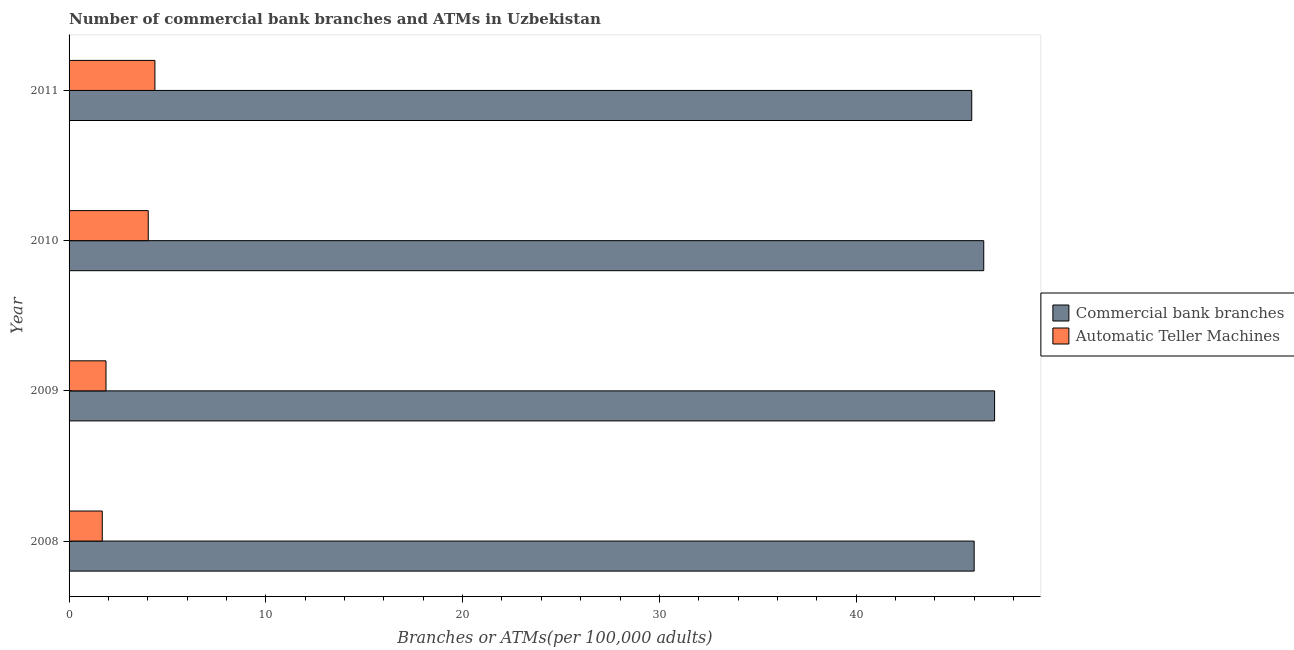How many groups of bars are there?
Offer a very short reply. 4. Are the number of bars per tick equal to the number of legend labels?
Make the answer very short. Yes. What is the label of the 2nd group of bars from the top?
Your answer should be compact. 2010. In how many cases, is the number of bars for a given year not equal to the number of legend labels?
Offer a terse response. 0. What is the number of commercal bank branches in 2009?
Provide a succinct answer. 47.03. Across all years, what is the maximum number of commercal bank branches?
Keep it short and to the point. 47.03. Across all years, what is the minimum number of atms?
Keep it short and to the point. 1.69. In which year was the number of commercal bank branches maximum?
Your answer should be very brief. 2009. What is the total number of atms in the graph?
Your response must be concise. 11.95. What is the difference between the number of atms in 2008 and that in 2010?
Your answer should be compact. -2.34. What is the difference between the number of atms in 2009 and the number of commercal bank branches in 2008?
Keep it short and to the point. -44.12. What is the average number of atms per year?
Make the answer very short. 2.99. In the year 2011, what is the difference between the number of atms and number of commercal bank branches?
Ensure brevity in your answer.  -41.51. What is the ratio of the number of commercal bank branches in 2008 to that in 2009?
Keep it short and to the point. 0.98. Is the difference between the number of atms in 2009 and 2011 greater than the difference between the number of commercal bank branches in 2009 and 2011?
Ensure brevity in your answer.  No. What is the difference between the highest and the second highest number of atms?
Give a very brief answer. 0.34. What is the difference between the highest and the lowest number of atms?
Offer a terse response. 2.68. What does the 2nd bar from the top in 2008 represents?
Ensure brevity in your answer.  Commercial bank branches. What does the 1st bar from the bottom in 2010 represents?
Give a very brief answer. Commercial bank branches. How many bars are there?
Give a very brief answer. 8. How many years are there in the graph?
Ensure brevity in your answer.  4. What is the difference between two consecutive major ticks on the X-axis?
Offer a terse response. 10. Does the graph contain grids?
Give a very brief answer. No. How many legend labels are there?
Your answer should be very brief. 2. What is the title of the graph?
Keep it short and to the point. Number of commercial bank branches and ATMs in Uzbekistan. What is the label or title of the X-axis?
Give a very brief answer. Branches or ATMs(per 100,0 adults). What is the label or title of the Y-axis?
Provide a short and direct response. Year. What is the Branches or ATMs(per 100,000 adults) in Commercial bank branches in 2008?
Offer a very short reply. 46. What is the Branches or ATMs(per 100,000 adults) of Automatic Teller Machines in 2008?
Give a very brief answer. 1.69. What is the Branches or ATMs(per 100,000 adults) of Commercial bank branches in 2009?
Keep it short and to the point. 47.03. What is the Branches or ATMs(per 100,000 adults) of Automatic Teller Machines in 2009?
Offer a terse response. 1.88. What is the Branches or ATMs(per 100,000 adults) of Commercial bank branches in 2010?
Your response must be concise. 46.48. What is the Branches or ATMs(per 100,000 adults) of Automatic Teller Machines in 2010?
Offer a very short reply. 4.02. What is the Branches or ATMs(per 100,000 adults) in Commercial bank branches in 2011?
Ensure brevity in your answer.  45.87. What is the Branches or ATMs(per 100,000 adults) of Automatic Teller Machines in 2011?
Offer a terse response. 4.36. Across all years, what is the maximum Branches or ATMs(per 100,000 adults) in Commercial bank branches?
Your response must be concise. 47.03. Across all years, what is the maximum Branches or ATMs(per 100,000 adults) of Automatic Teller Machines?
Offer a very short reply. 4.36. Across all years, what is the minimum Branches or ATMs(per 100,000 adults) of Commercial bank branches?
Offer a terse response. 45.87. Across all years, what is the minimum Branches or ATMs(per 100,000 adults) in Automatic Teller Machines?
Your answer should be compact. 1.69. What is the total Branches or ATMs(per 100,000 adults) in Commercial bank branches in the graph?
Make the answer very short. 185.39. What is the total Branches or ATMs(per 100,000 adults) of Automatic Teller Machines in the graph?
Offer a very short reply. 11.95. What is the difference between the Branches or ATMs(per 100,000 adults) in Commercial bank branches in 2008 and that in 2009?
Offer a terse response. -1.04. What is the difference between the Branches or ATMs(per 100,000 adults) in Automatic Teller Machines in 2008 and that in 2009?
Your response must be concise. -0.19. What is the difference between the Branches or ATMs(per 100,000 adults) of Commercial bank branches in 2008 and that in 2010?
Offer a very short reply. -0.49. What is the difference between the Branches or ATMs(per 100,000 adults) of Automatic Teller Machines in 2008 and that in 2010?
Provide a short and direct response. -2.34. What is the difference between the Branches or ATMs(per 100,000 adults) in Commercial bank branches in 2008 and that in 2011?
Make the answer very short. 0.12. What is the difference between the Branches or ATMs(per 100,000 adults) in Automatic Teller Machines in 2008 and that in 2011?
Give a very brief answer. -2.68. What is the difference between the Branches or ATMs(per 100,000 adults) of Commercial bank branches in 2009 and that in 2010?
Your answer should be compact. 0.55. What is the difference between the Branches or ATMs(per 100,000 adults) of Automatic Teller Machines in 2009 and that in 2010?
Keep it short and to the point. -2.15. What is the difference between the Branches or ATMs(per 100,000 adults) in Commercial bank branches in 2009 and that in 2011?
Ensure brevity in your answer.  1.16. What is the difference between the Branches or ATMs(per 100,000 adults) of Automatic Teller Machines in 2009 and that in 2011?
Provide a short and direct response. -2.49. What is the difference between the Branches or ATMs(per 100,000 adults) in Commercial bank branches in 2010 and that in 2011?
Offer a terse response. 0.61. What is the difference between the Branches or ATMs(per 100,000 adults) of Automatic Teller Machines in 2010 and that in 2011?
Your answer should be very brief. -0.34. What is the difference between the Branches or ATMs(per 100,000 adults) in Commercial bank branches in 2008 and the Branches or ATMs(per 100,000 adults) in Automatic Teller Machines in 2009?
Your answer should be compact. 44.12. What is the difference between the Branches or ATMs(per 100,000 adults) in Commercial bank branches in 2008 and the Branches or ATMs(per 100,000 adults) in Automatic Teller Machines in 2010?
Your response must be concise. 41.97. What is the difference between the Branches or ATMs(per 100,000 adults) in Commercial bank branches in 2008 and the Branches or ATMs(per 100,000 adults) in Automatic Teller Machines in 2011?
Make the answer very short. 41.63. What is the difference between the Branches or ATMs(per 100,000 adults) of Commercial bank branches in 2009 and the Branches or ATMs(per 100,000 adults) of Automatic Teller Machines in 2010?
Make the answer very short. 43.01. What is the difference between the Branches or ATMs(per 100,000 adults) in Commercial bank branches in 2009 and the Branches or ATMs(per 100,000 adults) in Automatic Teller Machines in 2011?
Ensure brevity in your answer.  42.67. What is the difference between the Branches or ATMs(per 100,000 adults) in Commercial bank branches in 2010 and the Branches or ATMs(per 100,000 adults) in Automatic Teller Machines in 2011?
Keep it short and to the point. 42.12. What is the average Branches or ATMs(per 100,000 adults) of Commercial bank branches per year?
Keep it short and to the point. 46.35. What is the average Branches or ATMs(per 100,000 adults) in Automatic Teller Machines per year?
Keep it short and to the point. 2.99. In the year 2008, what is the difference between the Branches or ATMs(per 100,000 adults) of Commercial bank branches and Branches or ATMs(per 100,000 adults) of Automatic Teller Machines?
Provide a succinct answer. 44.31. In the year 2009, what is the difference between the Branches or ATMs(per 100,000 adults) in Commercial bank branches and Branches or ATMs(per 100,000 adults) in Automatic Teller Machines?
Your response must be concise. 45.16. In the year 2010, what is the difference between the Branches or ATMs(per 100,000 adults) in Commercial bank branches and Branches or ATMs(per 100,000 adults) in Automatic Teller Machines?
Ensure brevity in your answer.  42.46. In the year 2011, what is the difference between the Branches or ATMs(per 100,000 adults) of Commercial bank branches and Branches or ATMs(per 100,000 adults) of Automatic Teller Machines?
Make the answer very short. 41.51. What is the ratio of the Branches or ATMs(per 100,000 adults) of Commercial bank branches in 2008 to that in 2009?
Your answer should be compact. 0.98. What is the ratio of the Branches or ATMs(per 100,000 adults) of Automatic Teller Machines in 2008 to that in 2009?
Provide a succinct answer. 0.9. What is the ratio of the Branches or ATMs(per 100,000 adults) of Automatic Teller Machines in 2008 to that in 2010?
Your answer should be very brief. 0.42. What is the ratio of the Branches or ATMs(per 100,000 adults) in Commercial bank branches in 2008 to that in 2011?
Give a very brief answer. 1. What is the ratio of the Branches or ATMs(per 100,000 adults) of Automatic Teller Machines in 2008 to that in 2011?
Keep it short and to the point. 0.39. What is the ratio of the Branches or ATMs(per 100,000 adults) of Commercial bank branches in 2009 to that in 2010?
Your response must be concise. 1.01. What is the ratio of the Branches or ATMs(per 100,000 adults) in Automatic Teller Machines in 2009 to that in 2010?
Provide a short and direct response. 0.47. What is the ratio of the Branches or ATMs(per 100,000 adults) of Commercial bank branches in 2009 to that in 2011?
Give a very brief answer. 1.03. What is the ratio of the Branches or ATMs(per 100,000 adults) of Automatic Teller Machines in 2009 to that in 2011?
Keep it short and to the point. 0.43. What is the ratio of the Branches or ATMs(per 100,000 adults) in Commercial bank branches in 2010 to that in 2011?
Ensure brevity in your answer.  1.01. What is the ratio of the Branches or ATMs(per 100,000 adults) of Automatic Teller Machines in 2010 to that in 2011?
Your answer should be compact. 0.92. What is the difference between the highest and the second highest Branches or ATMs(per 100,000 adults) of Commercial bank branches?
Make the answer very short. 0.55. What is the difference between the highest and the second highest Branches or ATMs(per 100,000 adults) in Automatic Teller Machines?
Your answer should be compact. 0.34. What is the difference between the highest and the lowest Branches or ATMs(per 100,000 adults) in Commercial bank branches?
Offer a very short reply. 1.16. What is the difference between the highest and the lowest Branches or ATMs(per 100,000 adults) in Automatic Teller Machines?
Provide a succinct answer. 2.68. 